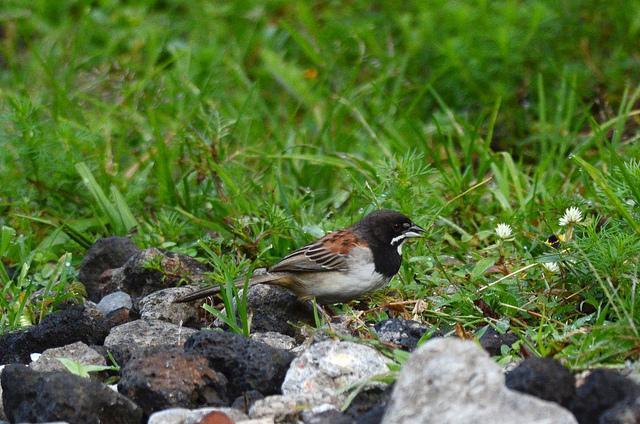How many birds?
Give a very brief answer. 1. How many people are wearing glasses?
Give a very brief answer. 0. 